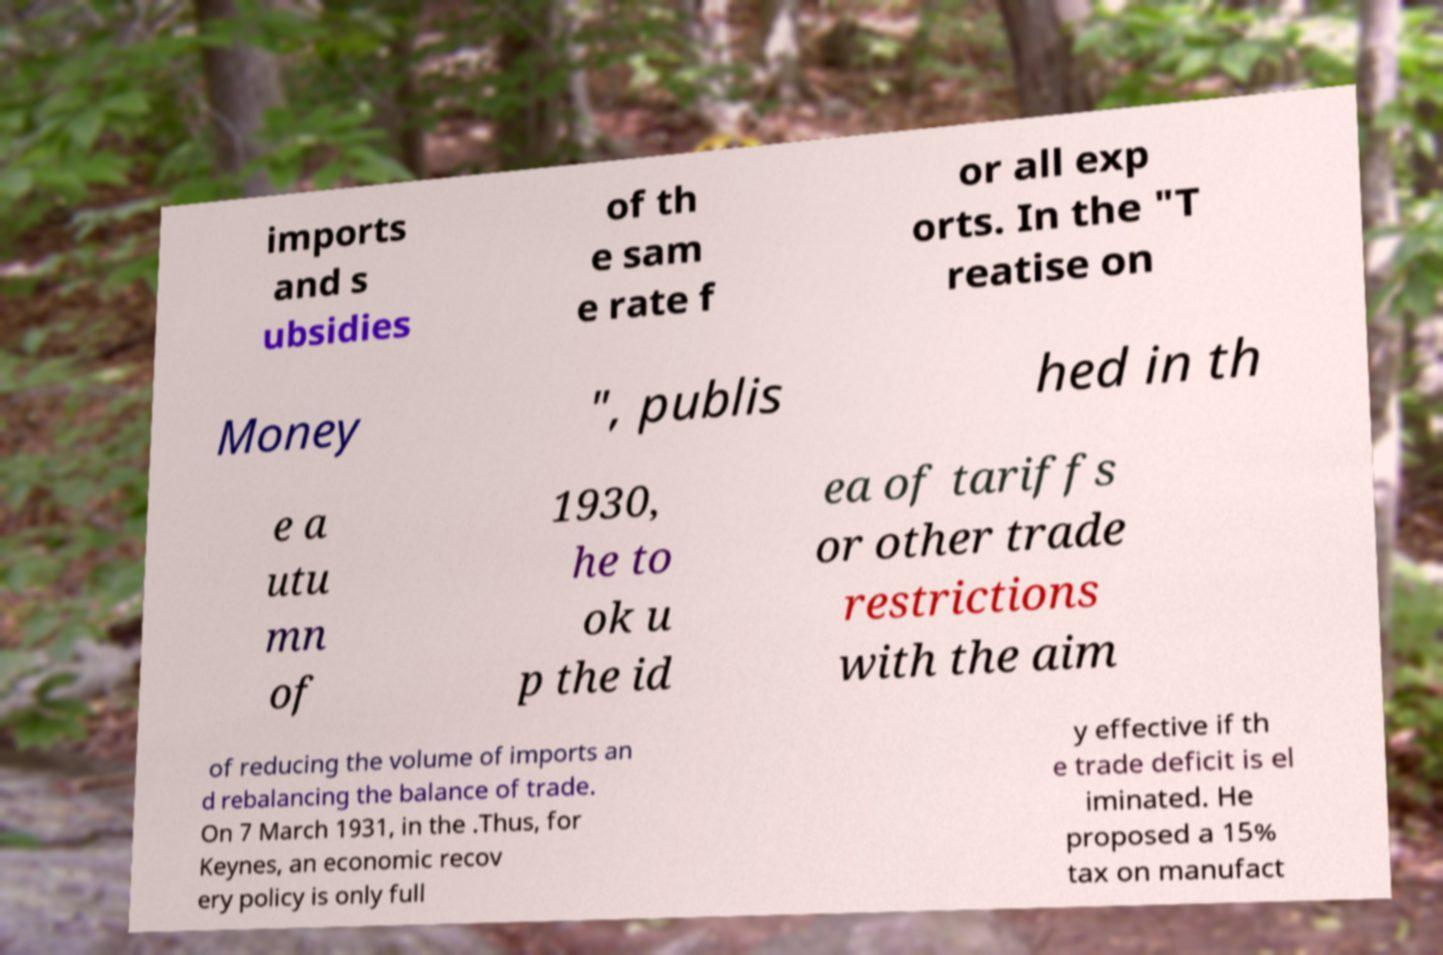For documentation purposes, I need the text within this image transcribed. Could you provide that? imports and s ubsidies of th e sam e rate f or all exp orts. In the "T reatise on Money ", publis hed in th e a utu mn of 1930, he to ok u p the id ea of tariffs or other trade restrictions with the aim of reducing the volume of imports an d rebalancing the balance of trade. On 7 March 1931, in the .Thus, for Keynes, an economic recov ery policy is only full y effective if th e trade deficit is el iminated. He proposed a 15% tax on manufact 